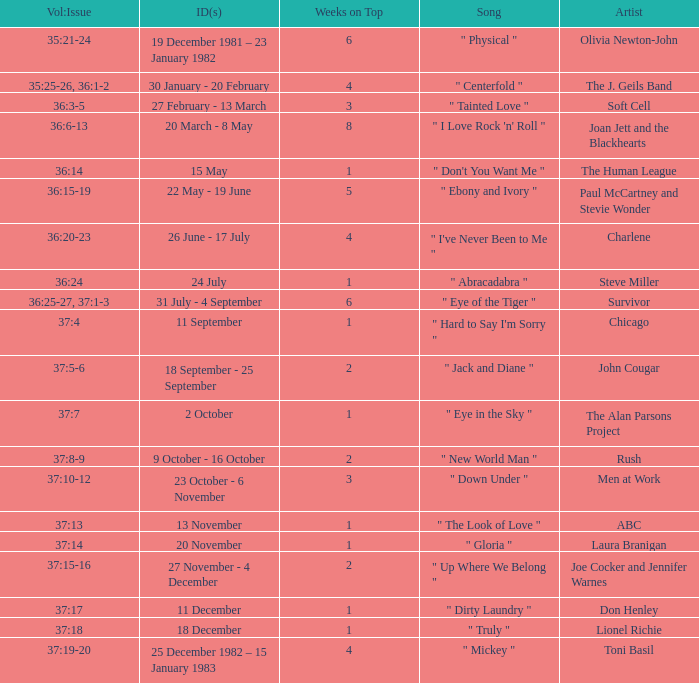Which Weeks on Top have an Issue Date(s) of 20 november? 1.0. 